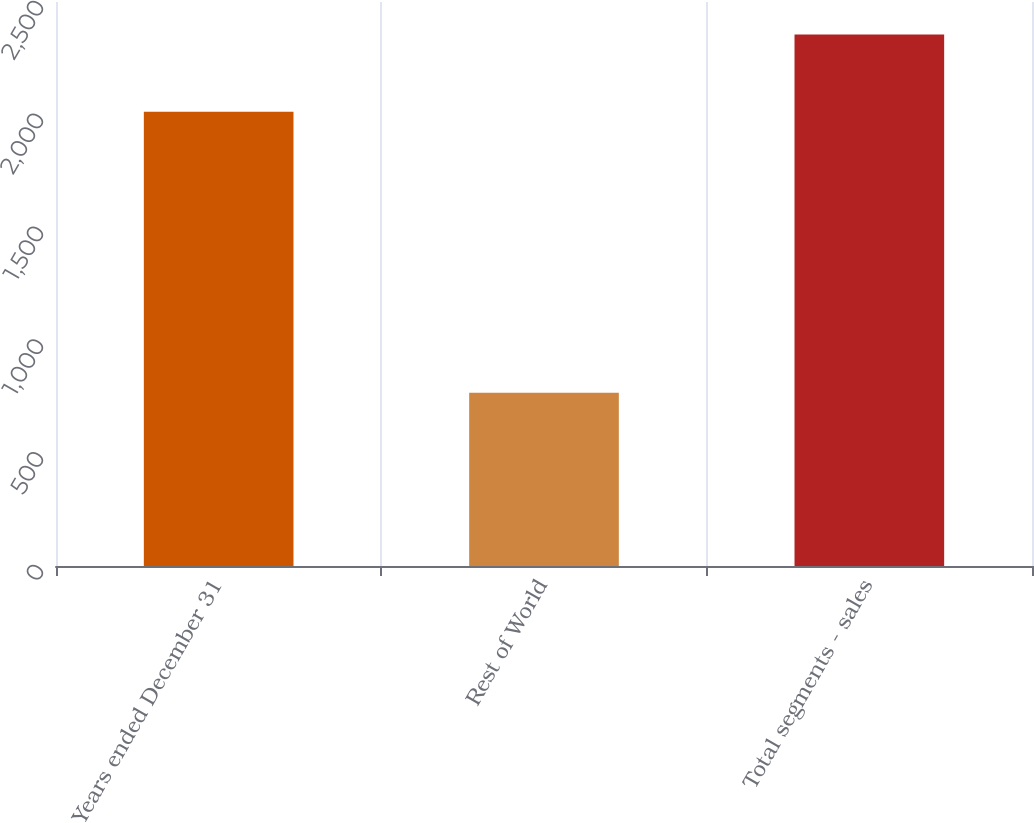Convert chart to OTSL. <chart><loc_0><loc_0><loc_500><loc_500><bar_chart><fcel>Years ended December 31<fcel>Rest of World<fcel>Total segments - sales<nl><fcel>2014<fcel>768.3<fcel>2356<nl></chart> 